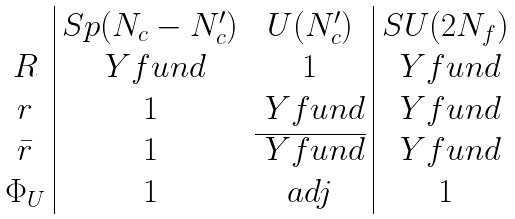<formula> <loc_0><loc_0><loc_500><loc_500>\begin{array} { c | c c | c c } & S p ( N _ { c } - N _ { c } ^ { \prime } ) & U ( N _ { c } ^ { \prime } ) & S U ( 2 N _ { f } ) \\ R & \ Y f u n d & 1 & \ Y f u n d \\ r & 1 & \ Y f u n d & \ Y f u n d \\ \bar { r } & 1 & \overline { \ Y f u n d } & \ Y f u n d \\ \Phi _ { U } & 1 & a d j & 1 \\ \end{array}</formula> 